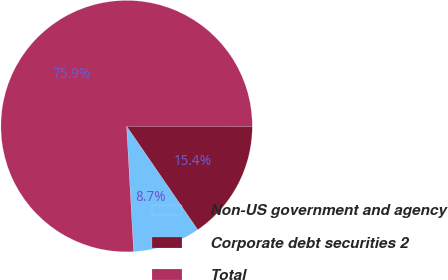<chart> <loc_0><loc_0><loc_500><loc_500><pie_chart><fcel>Non-US government and agency<fcel>Corporate debt securities 2<fcel>Total<nl><fcel>8.69%<fcel>15.41%<fcel>75.89%<nl></chart> 